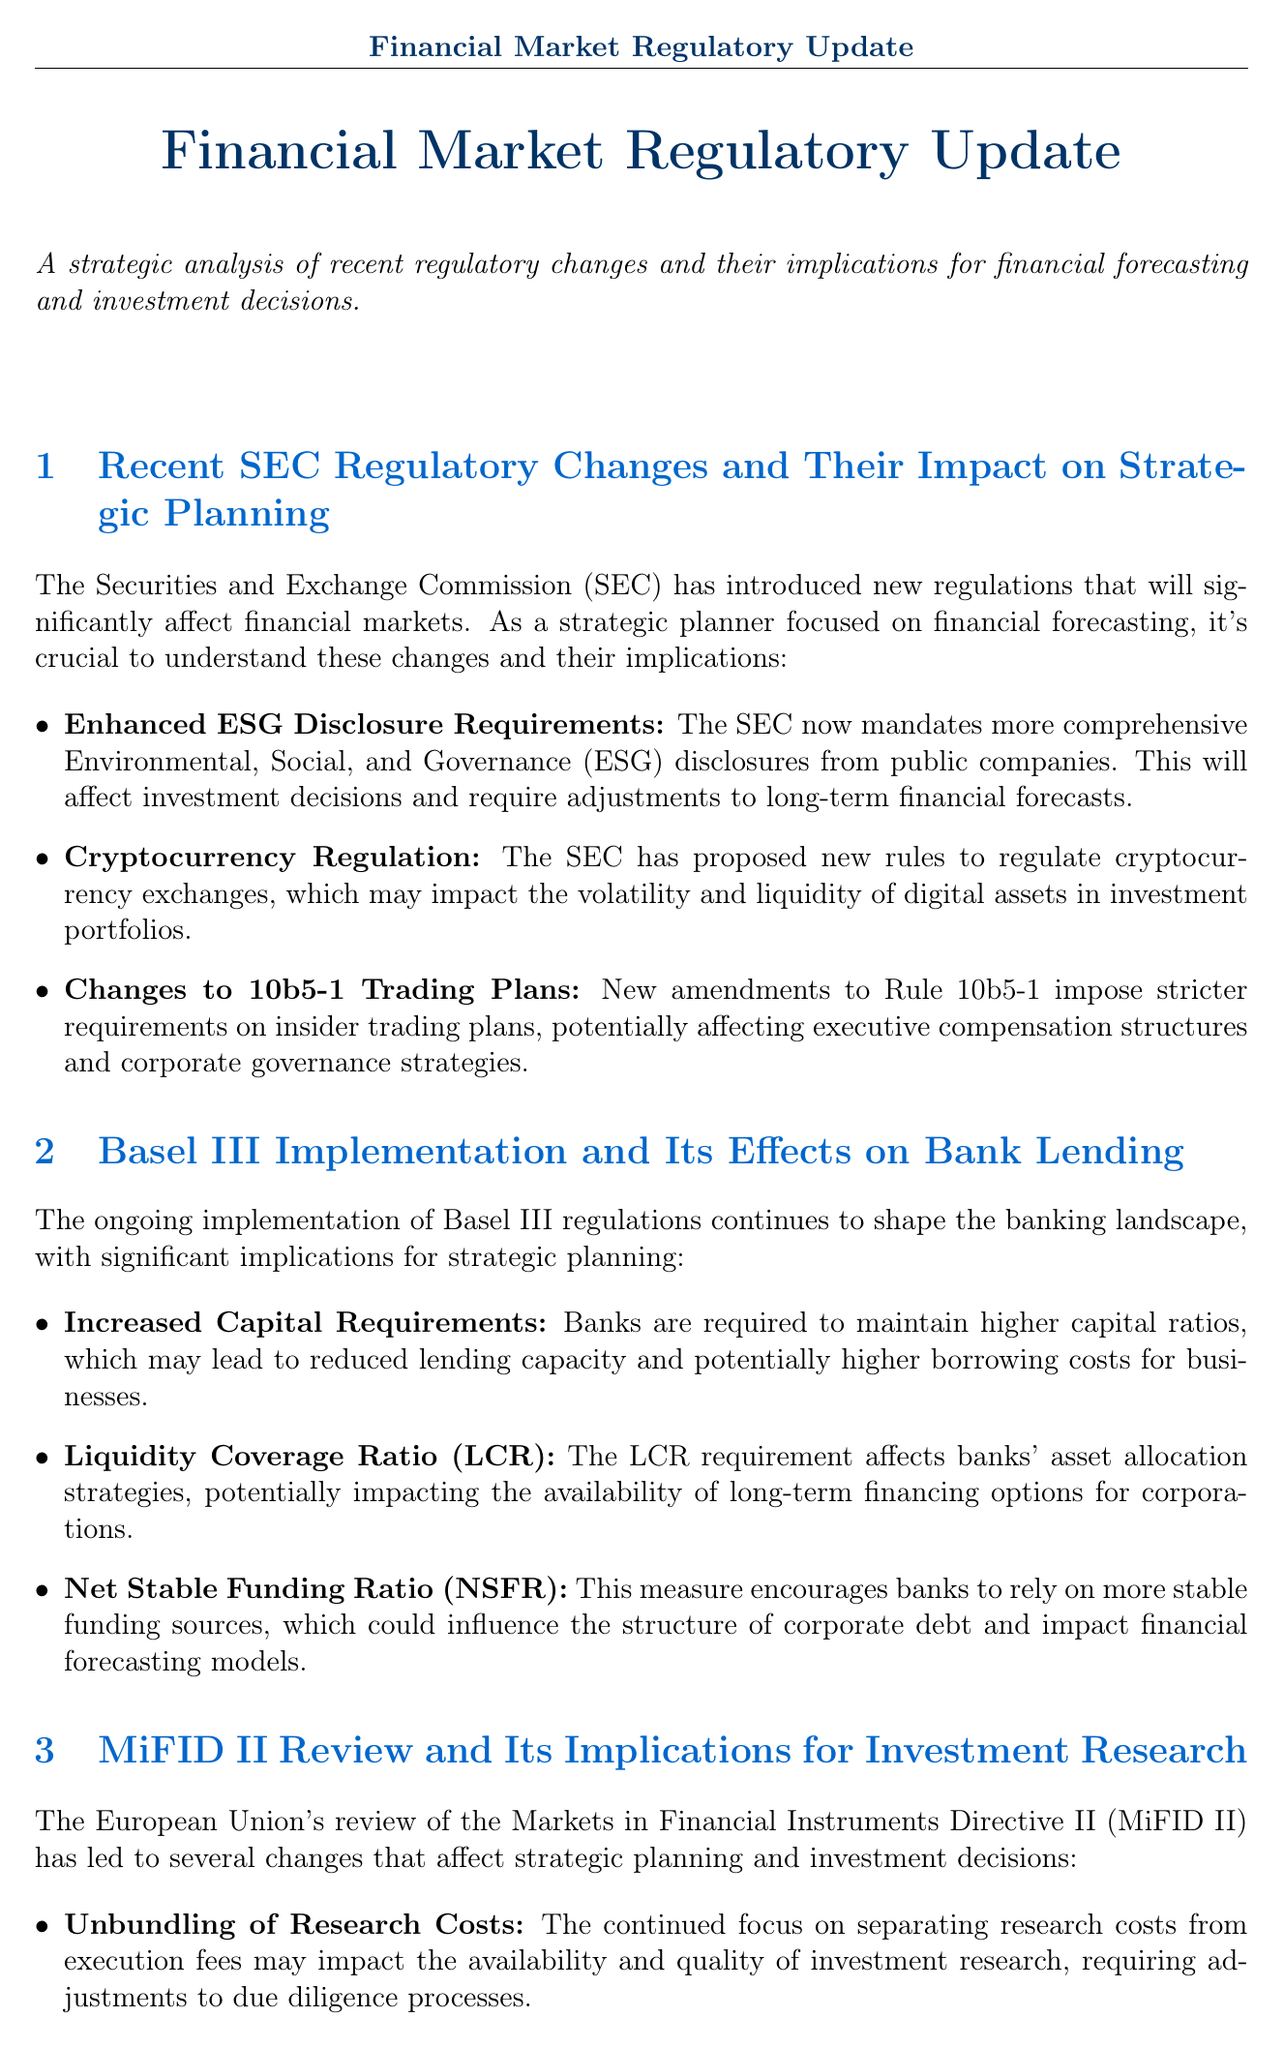What are the new regulations introduced by the SEC? The SEC introduced regulations related to enhanced ESG disclosure requirements, cryptocurrency regulation, and changes to 10b5-1 trading plans.
Answer: SEO disclosure, cryptocurrency regulation, 10b5-1 plans What does the Basel III regulation require? Basel III requires banks to maintain higher capital ratios.
Answer: Higher capital ratios How does the MiFID II review affect investment research costs? The MiFID II review focuses on unbundling research costs from execution fees.
Answer: Unbundling research costs What does the Volcker Rule allow according to recent modifications? Recent modifications to the Volcker Rule ease proprietary trading restrictions for banks.
Answer: Easing of proprietary trading restrictions What is the effect of FATCA on international investments? The implementation of FATCA affects international investment strategies and tax planning.
Answer: Affects international investment strategies What has caused regulatory divergence in the UK post-Brexit? Brexit has led to regulatory divergence in financial services.
Answer: Brexit How does the SEC's ESG disclosure mandate influence financial forecasts? The SEC's ESG disclosure mandate requires adjustments to long-term financial forecasts.
Answer: Adjustments to long-term financial forecasts What does the LCR requirement affect? The LCR requirement affects banks' asset allocation strategies.
Answer: Banks' asset allocation strategies What opportunity arises from China's financial market changes? The removal of foreign ownership caps in China creates new opportunities for international investment strategies.
Answer: Removal of foreign ownership caps 